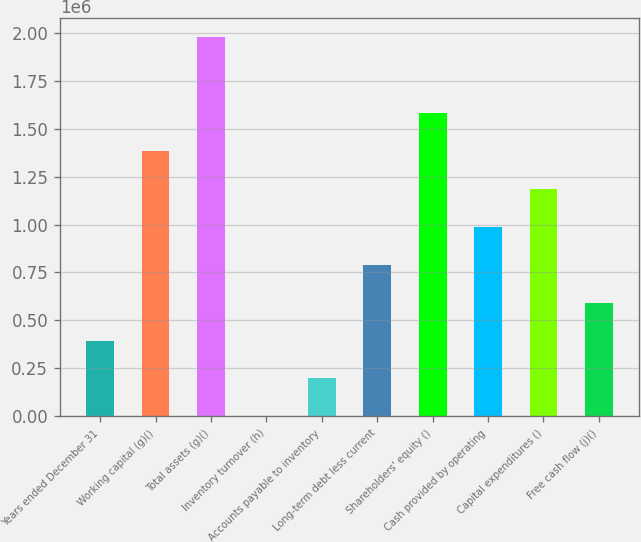<chart> <loc_0><loc_0><loc_500><loc_500><bar_chart><fcel>Years ended December 31<fcel>Working capital (g)()<fcel>Total assets (g)()<fcel>Inventory turnover (h)<fcel>Accounts payable to inventory<fcel>Long-term debt less current<fcel>Shareholders' equity ()<fcel>Cash provided by operating<fcel>Capital expenditures ()<fcel>Free cash flow (j)()<nl><fcel>395500<fcel>1.38425e+06<fcel>1.9775e+06<fcel>1.6<fcel>197751<fcel>790999<fcel>1.582e+06<fcel>988749<fcel>1.1865e+06<fcel>593250<nl></chart> 